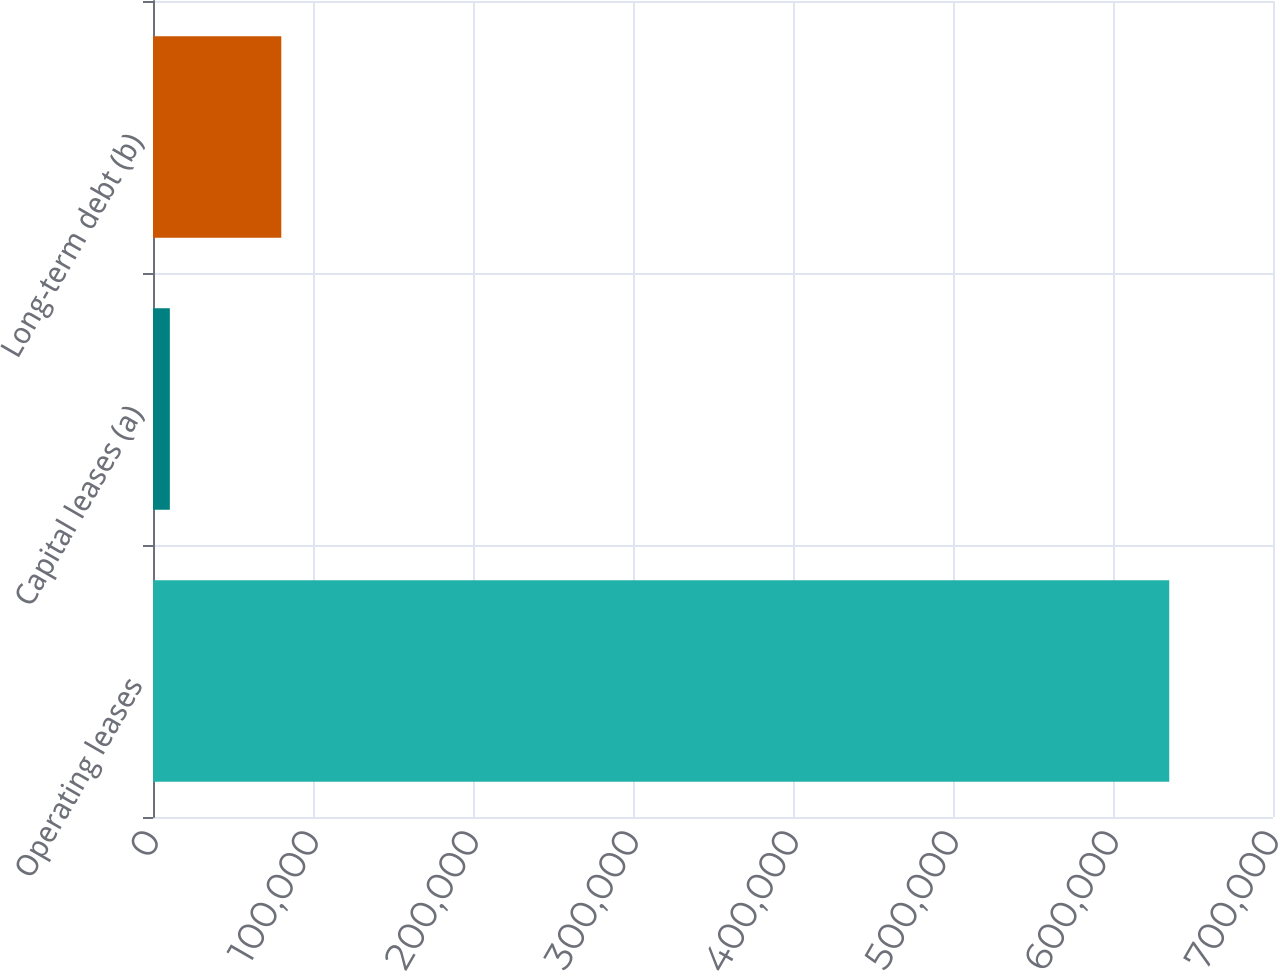Convert chart to OTSL. <chart><loc_0><loc_0><loc_500><loc_500><bar_chart><fcel>Operating leases<fcel>Capital leases (a)<fcel>Long-term debt (b)<nl><fcel>635161<fcel>10528<fcel>80181<nl></chart> 